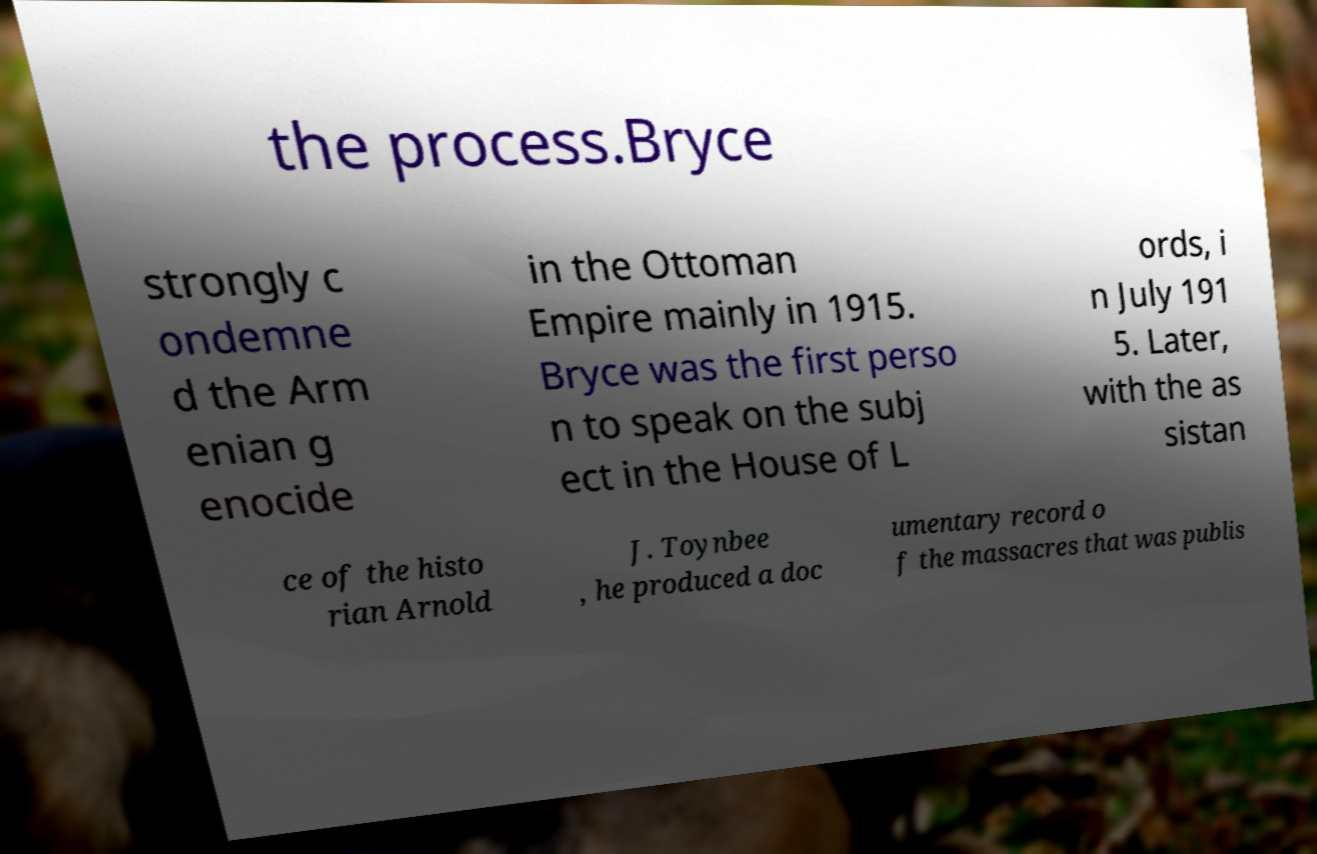Can you accurately transcribe the text from the provided image for me? the process.Bryce strongly c ondemne d the Arm enian g enocide in the Ottoman Empire mainly in 1915. Bryce was the first perso n to speak on the subj ect in the House of L ords, i n July 191 5. Later, with the as sistan ce of the histo rian Arnold J. Toynbee , he produced a doc umentary record o f the massacres that was publis 